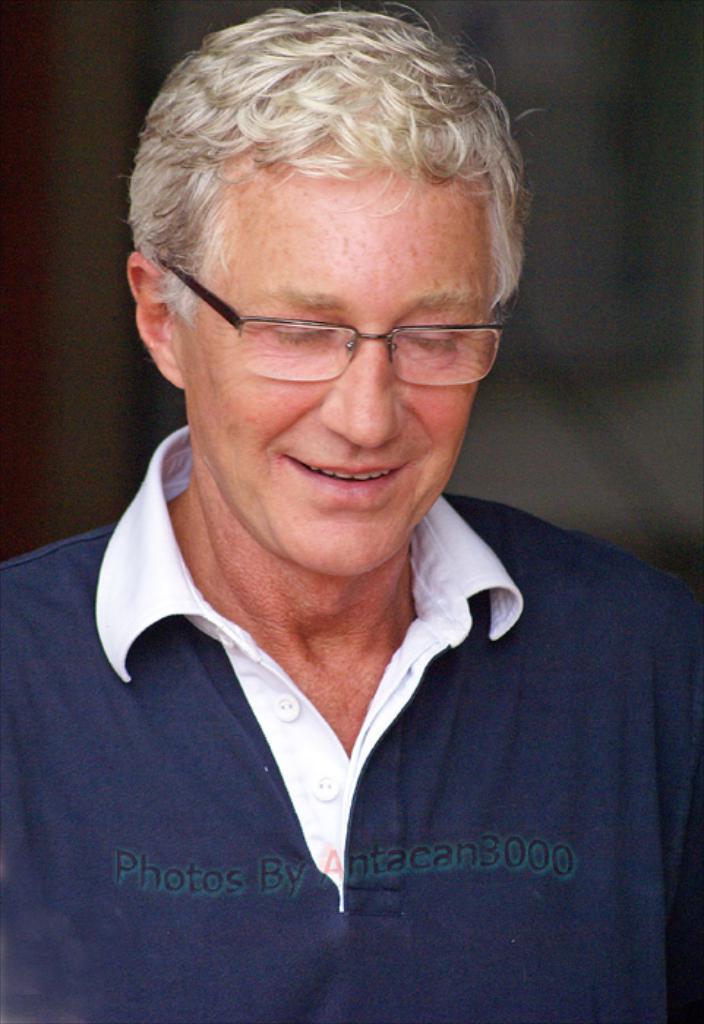Describe this image in one or two sentences. In this image I can see the person and the person is wearing blue and white color shirt and I can see the dark background. 